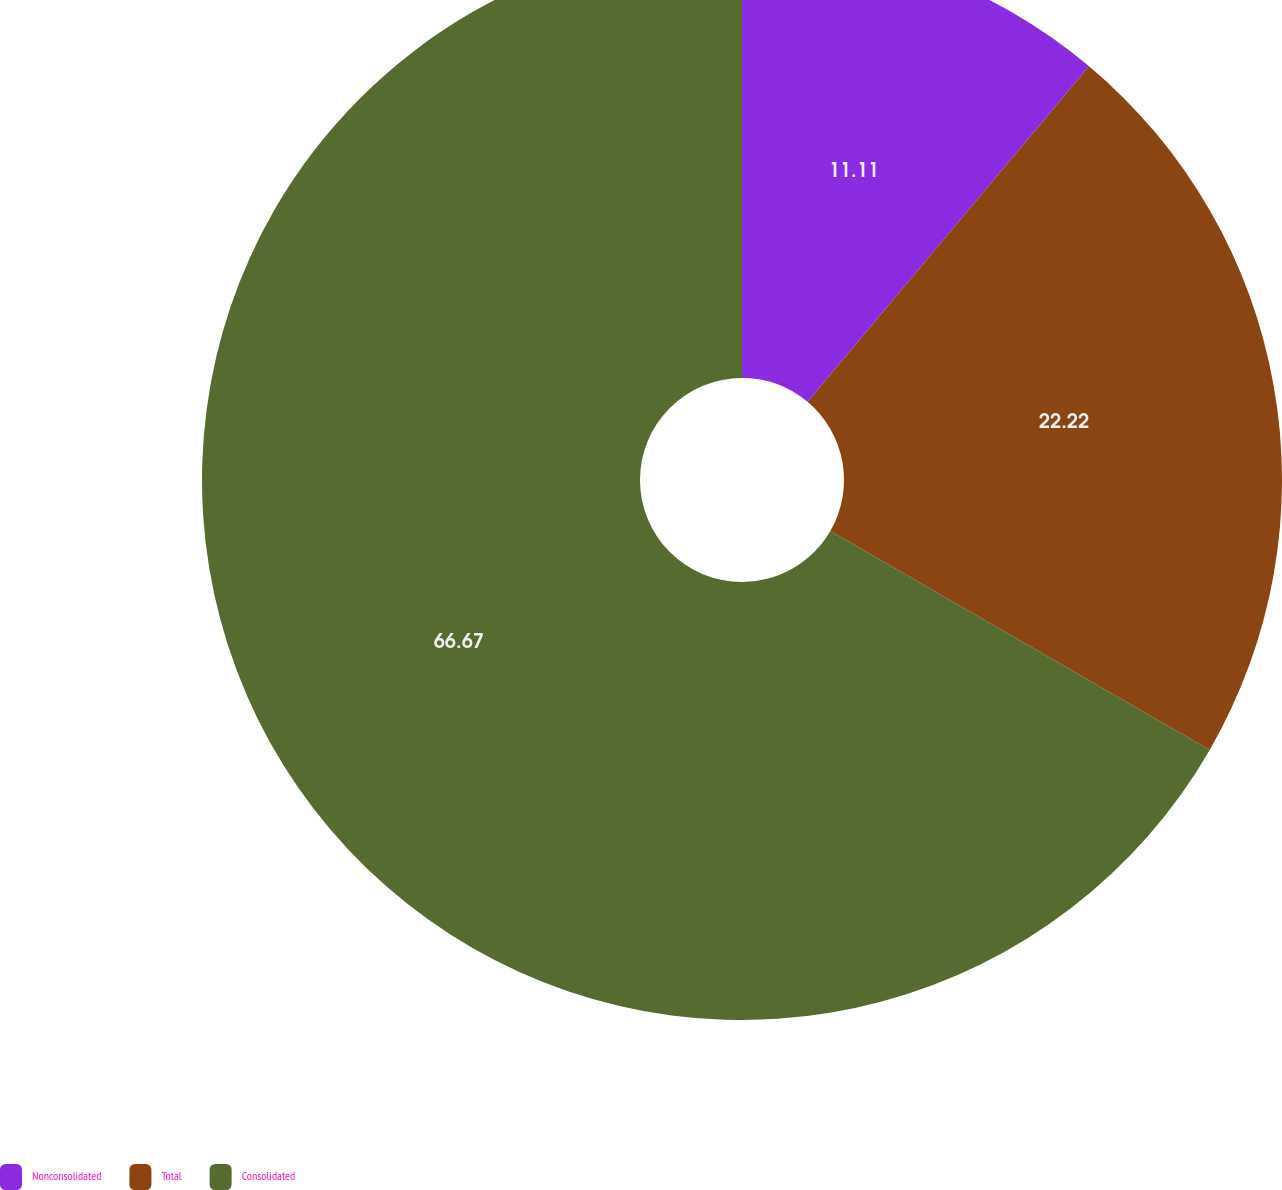Convert chart to OTSL. <chart><loc_0><loc_0><loc_500><loc_500><pie_chart><fcel>Nonconsolidated<fcel>Total<fcel>Consolidated<nl><fcel>11.11%<fcel>22.22%<fcel>66.67%<nl></chart> 